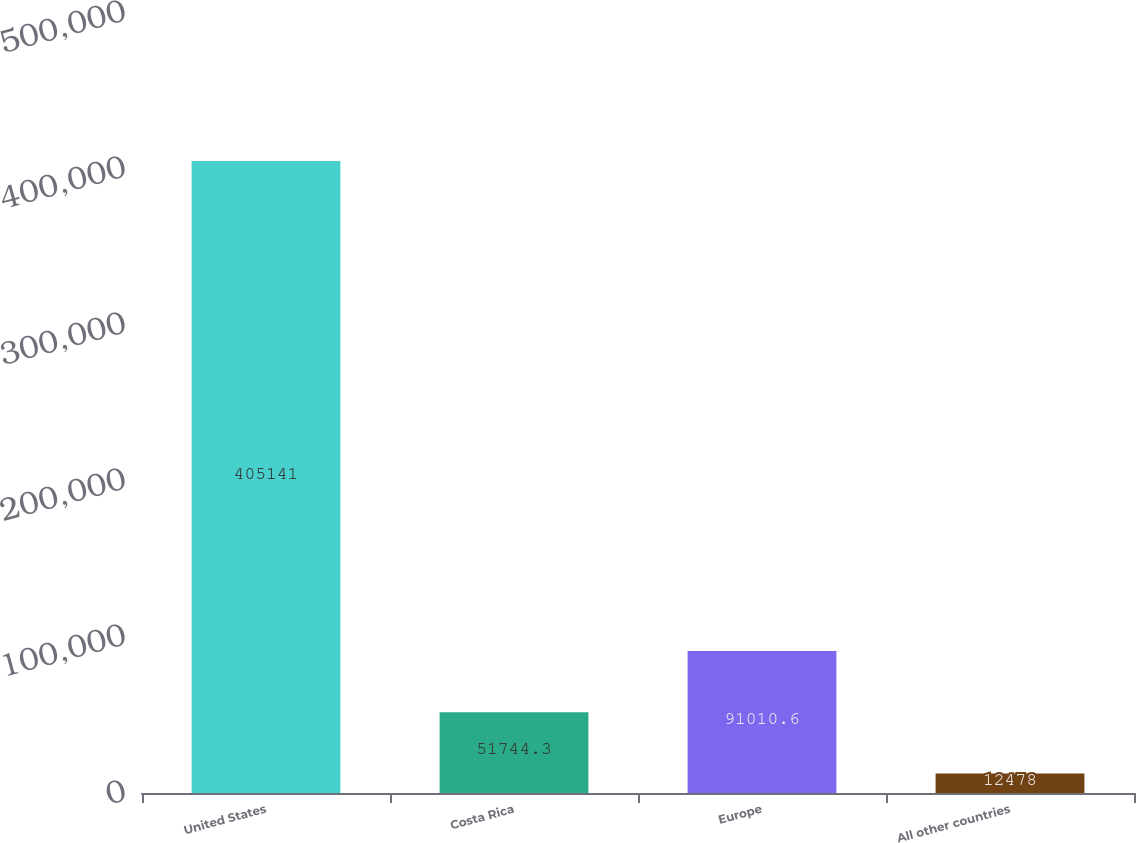Convert chart to OTSL. <chart><loc_0><loc_0><loc_500><loc_500><bar_chart><fcel>United States<fcel>Costa Rica<fcel>Europe<fcel>All other countries<nl><fcel>405141<fcel>51744.3<fcel>91010.6<fcel>12478<nl></chart> 